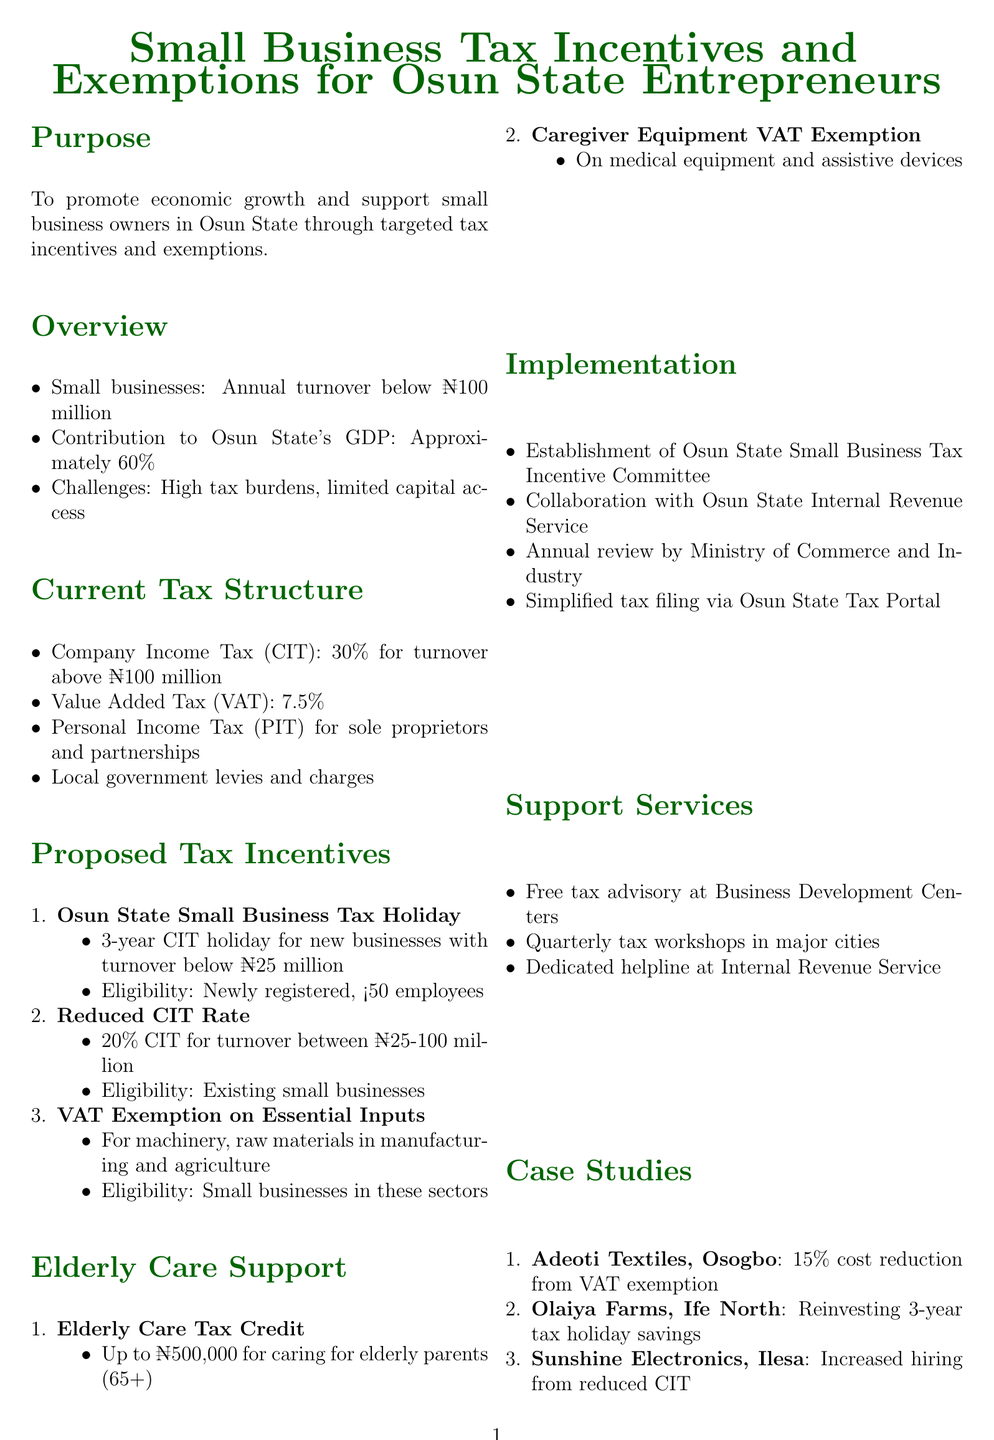What is the annual turnover limit for small businesses in Osun State? The annual turnover limit for small businesses in Osun State is defined as below ₦100 million.
Answer: below ₦100 million What is the VAT rate applicable to small businesses? The document states that the Value Added Tax (VAT) rate is 7.5%.
Answer: 7.5% How long is the tax holiday for new small businesses with turnover below ₦25 million? Newly registered small businesses with turnover below ₦25 million are eligible for a 3-year tax holiday on Company Income Tax.
Answer: 3 years What is the tax credit amount for small business owners caring for elderly parents? The document specifies a tax credit of up to ₦500,000 for small business owners caring for elderly parents aged 65 and above.
Answer: ₦500,000 Which committee is established for the implementation of tax incentives? The establishment of the Osun State Small Business Tax Incentive Committee (OSBTIC) is mentioned for implementation.
Answer: Osun State Small Business Tax Incentive Committee (OSBTIC) Why would a small business in agriculture apply for VAT exemption? The VAT exemption applies to machinery, raw materials, and other essential inputs in manufacturing and agriculture, helping to lower costs.
Answer: To lower costs What is the effective date of the policy document? The effective date for the policy is stated as January 1, 2024.
Answer: January 1, 2024 How often will the incentives be reviewed? The document mentions that there will be an annual review of the incentives.
Answer: Annually 